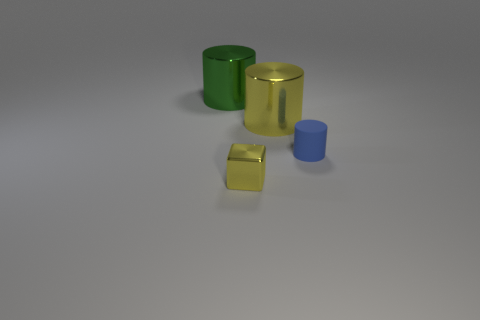Is the large yellow thing made of the same material as the small thing that is on the right side of the small yellow metal object?
Your answer should be compact. No. How many metal things are on the right side of the big cylinder that is left of the tiny thing that is left of the blue matte cylinder?
Offer a very short reply. 2. What number of gray things are either tiny shiny blocks or large metallic things?
Provide a succinct answer. 0. There is a yellow thing that is behind the blue cylinder; what is its shape?
Provide a succinct answer. Cylinder. The other object that is the same size as the green object is what color?
Give a very brief answer. Yellow. There is a green object; is its shape the same as the object right of the big yellow metal cylinder?
Your answer should be compact. Yes. What is the material of the tiny thing behind the small object to the left of the large cylinder that is right of the small yellow object?
Keep it short and to the point. Rubber. How many big things are blue cylinders or green matte objects?
Give a very brief answer. 0. What number of other objects are there of the same size as the blue rubber cylinder?
Offer a terse response. 1. Is the shape of the small thing that is right of the tiny metal thing the same as  the small yellow object?
Your response must be concise. No. 